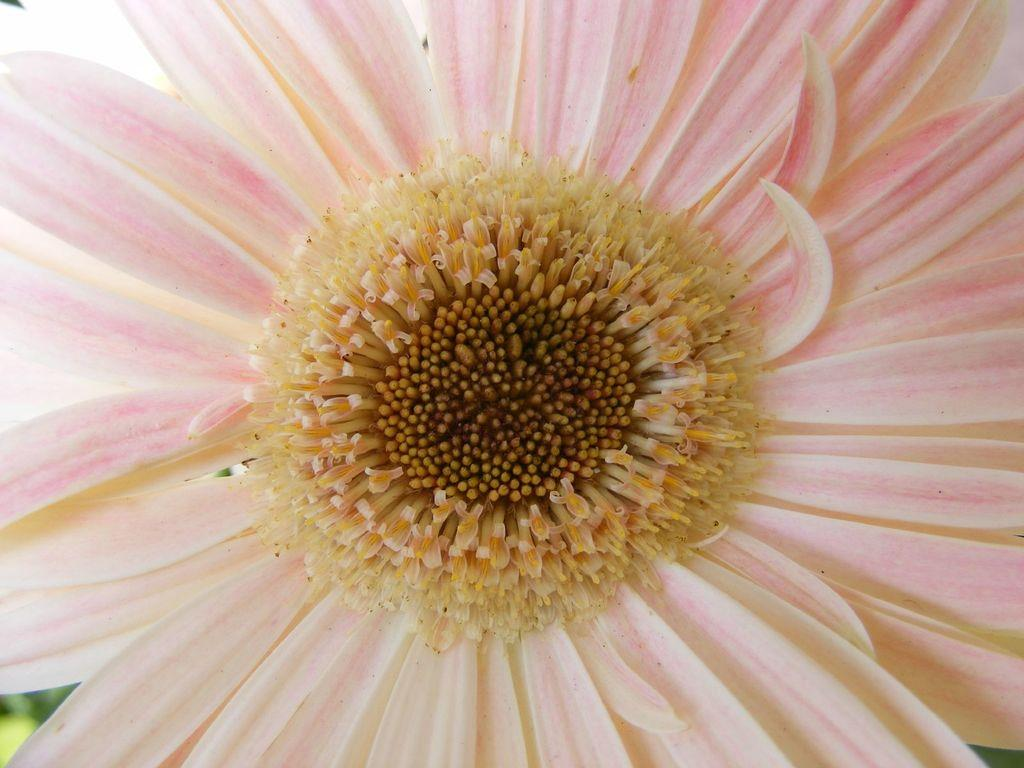What is the main subject of the image? There is a flower in the image. What color is the flower? The flower is pink in color. What type of fuel is being used by the cast in the image? There is no cast or fuel present in the image; it features a pink flower. 